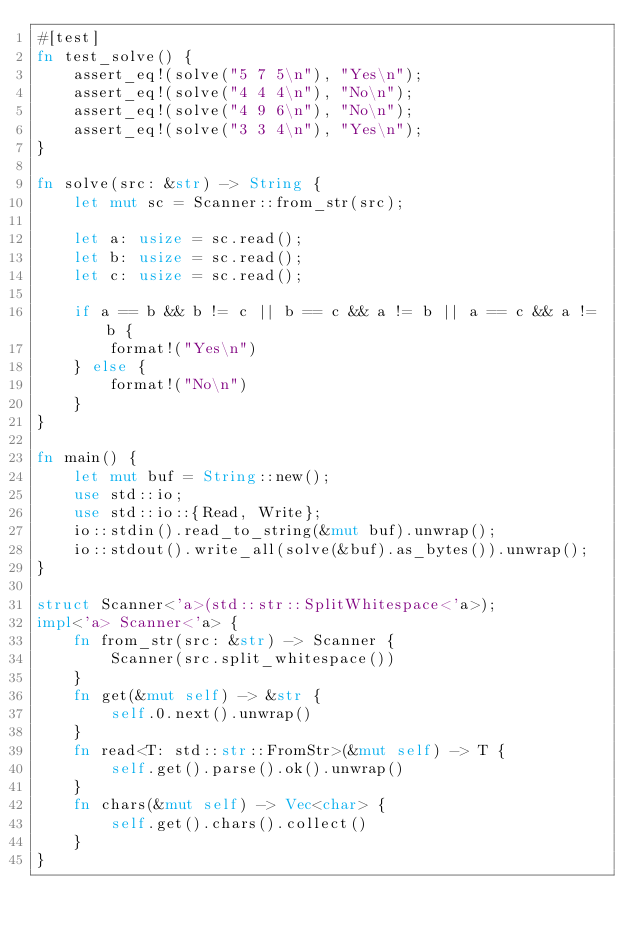Convert code to text. <code><loc_0><loc_0><loc_500><loc_500><_Rust_>#[test]
fn test_solve() {
    assert_eq!(solve("5 7 5\n"), "Yes\n");
    assert_eq!(solve("4 4 4\n"), "No\n");
    assert_eq!(solve("4 9 6\n"), "No\n");
    assert_eq!(solve("3 3 4\n"), "Yes\n");
}

fn solve(src: &str) -> String {
    let mut sc = Scanner::from_str(src);

    let a: usize = sc.read();
    let b: usize = sc.read();
    let c: usize = sc.read();

    if a == b && b != c || b == c && a != b || a == c && a != b {
        format!("Yes\n")
    } else {
        format!("No\n")
    }
}

fn main() {
    let mut buf = String::new();
    use std::io;
    use std::io::{Read, Write};
    io::stdin().read_to_string(&mut buf).unwrap();
    io::stdout().write_all(solve(&buf).as_bytes()).unwrap();
}

struct Scanner<'a>(std::str::SplitWhitespace<'a>);
impl<'a> Scanner<'a> {
    fn from_str(src: &str) -> Scanner {
        Scanner(src.split_whitespace())
    }
    fn get(&mut self) -> &str {
        self.0.next().unwrap()
    }
    fn read<T: std::str::FromStr>(&mut self) -> T {
        self.get().parse().ok().unwrap()
    }
    fn chars(&mut self) -> Vec<char> {
        self.get().chars().collect()
    }
}</code> 